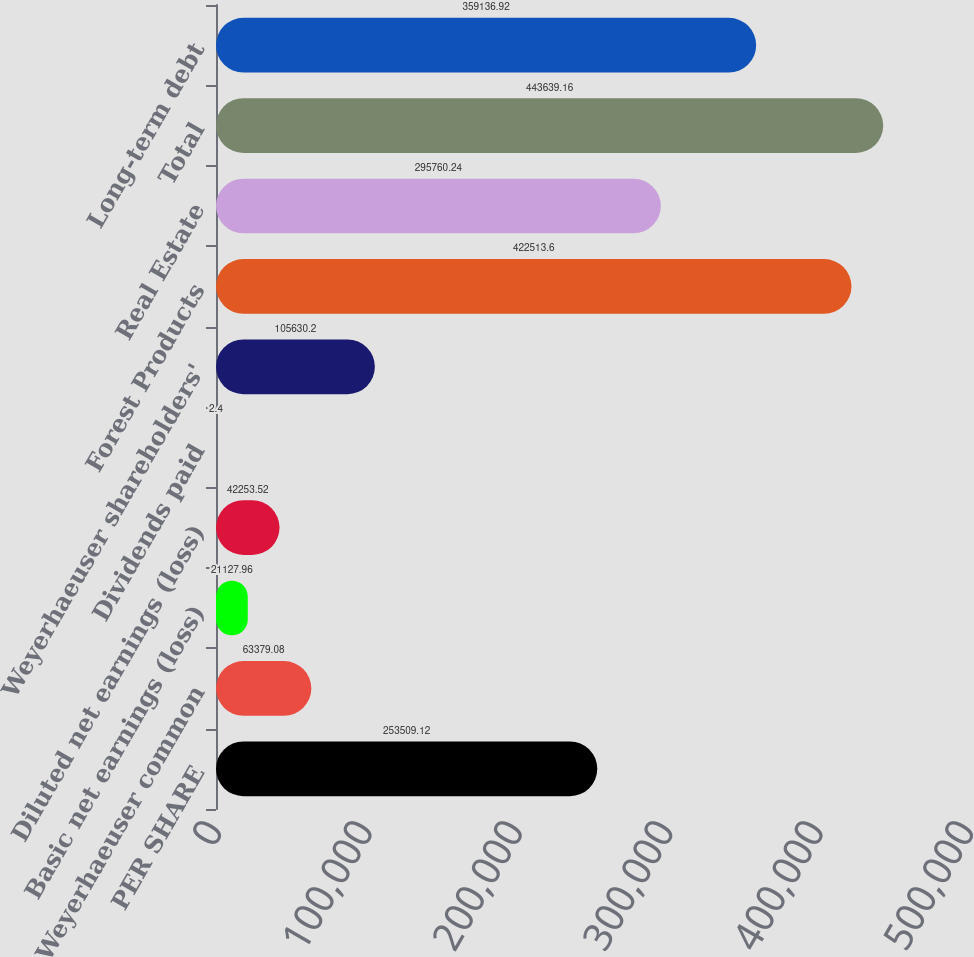<chart> <loc_0><loc_0><loc_500><loc_500><bar_chart><fcel>PER SHARE<fcel>Weyerhaeuser common<fcel>Basic net earnings (loss)<fcel>Diluted net earnings (loss)<fcel>Dividends paid<fcel>Weyerhaeuser shareholders'<fcel>Forest Products<fcel>Real Estate<fcel>Total<fcel>Long-term debt<nl><fcel>253509<fcel>63379.1<fcel>21128<fcel>42253.5<fcel>2.4<fcel>105630<fcel>422514<fcel>295760<fcel>443639<fcel>359137<nl></chart> 